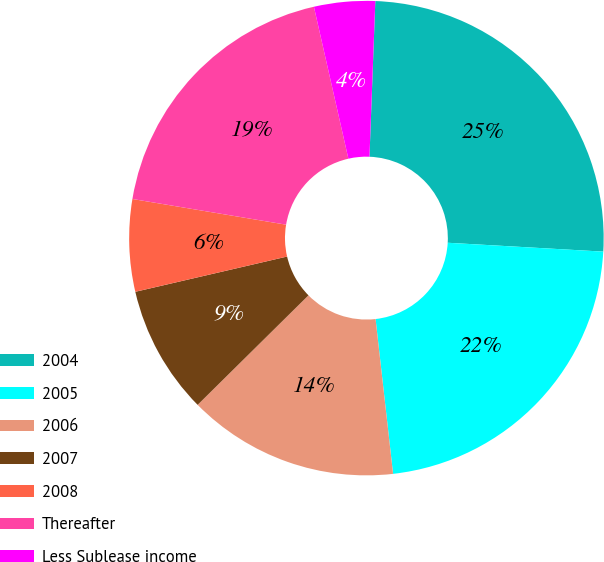<chart> <loc_0><loc_0><loc_500><loc_500><pie_chart><fcel>2004<fcel>2005<fcel>2006<fcel>2007<fcel>2008<fcel>Thereafter<fcel>Less Sublease income<nl><fcel>25.31%<fcel>22.3%<fcel>14.39%<fcel>8.77%<fcel>6.27%<fcel>18.81%<fcel>4.15%<nl></chart> 